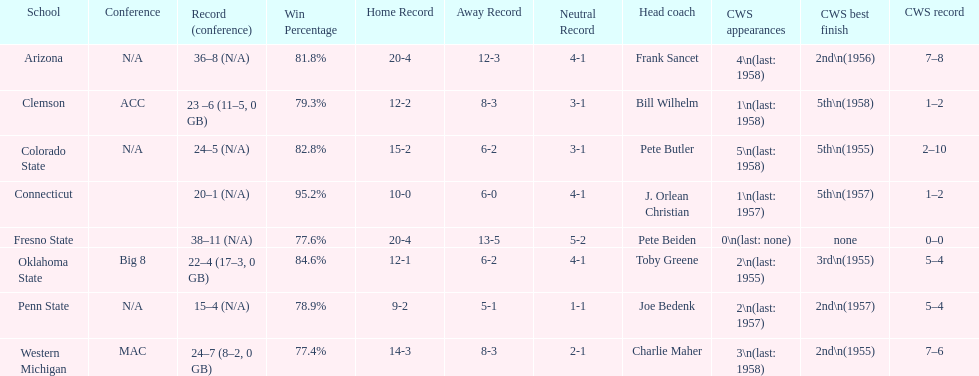Does clemson or western michigan have more cws appearances? Western Michigan. 